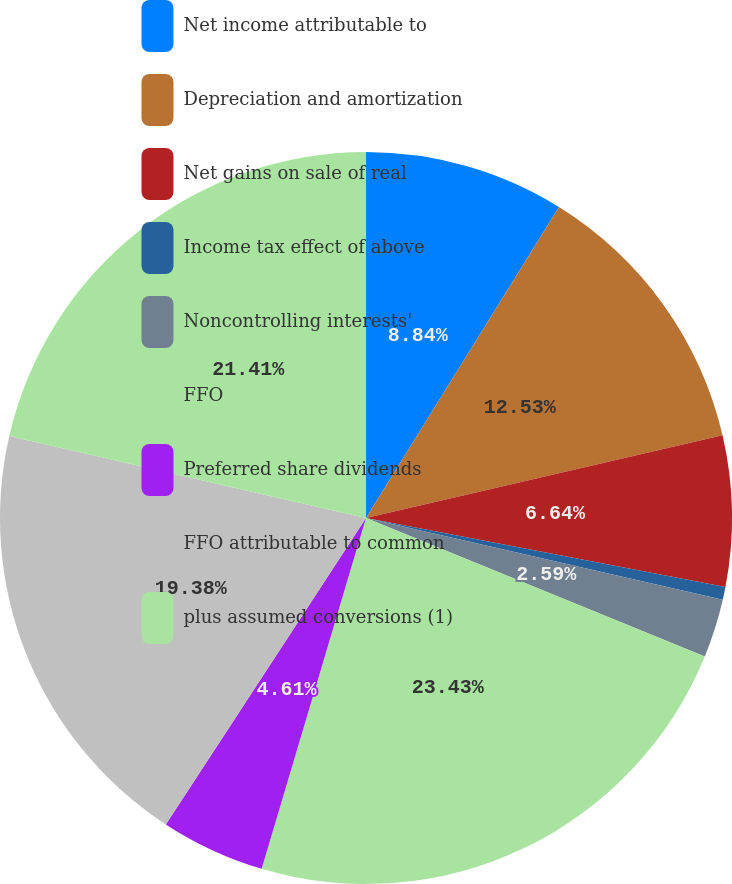Convert chart. <chart><loc_0><loc_0><loc_500><loc_500><pie_chart><fcel>Net income attributable to<fcel>Depreciation and amortization<fcel>Net gains on sale of real<fcel>Income tax effect of above<fcel>Noncontrolling interests'<fcel>FFO<fcel>Preferred share dividends<fcel>FFO attributable to common<fcel>plus assumed conversions (1)<nl><fcel>8.84%<fcel>12.53%<fcel>6.64%<fcel>0.57%<fcel>2.59%<fcel>23.42%<fcel>4.61%<fcel>19.38%<fcel>21.4%<nl></chart> 